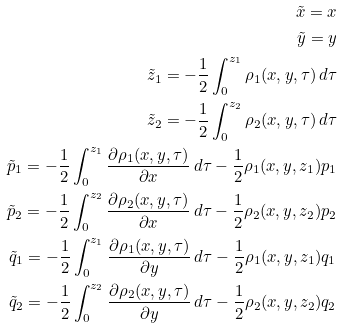<formula> <loc_0><loc_0><loc_500><loc_500>\tilde { x } = x \\ \tilde { y } = y \\ \tilde { z } _ { 1 } = - \frac { 1 } { 2 } \int _ { 0 } ^ { z _ { 1 } } \rho _ { 1 } ( x , y , \tau ) \, d \tau \\ \tilde { z } _ { 2 } = - \frac { 1 } { 2 } \int _ { 0 } ^ { z _ { 2 } } \rho _ { 2 } ( x , y , \tau ) \, d \tau \\ \tilde { p } _ { 1 } = - \frac { 1 } { 2 } \int _ { 0 } ^ { z _ { 1 } } \frac { \partial \rho _ { 1 } ( x , y , \tau ) } { \partial x } \, d \tau - \frac { 1 } { 2 } \rho _ { 1 } ( x , y , z _ { 1 } ) p _ { 1 } \\ \tilde { p } _ { 2 } = - \frac { 1 } { 2 } \int _ { 0 } ^ { z _ { 2 } } \frac { \partial \rho _ { 2 } ( x , y , \tau ) } { \partial x } \, d \tau - \frac { 1 } { 2 } \rho _ { 2 } ( x , y , z _ { 2 } ) p _ { 2 } \\ \tilde { q } _ { 1 } = - \frac { 1 } { 2 } \int _ { 0 } ^ { z _ { 1 } } \frac { \partial \rho _ { 1 } ( x , y , \tau ) } { \partial y } \, d \tau - \frac { 1 } { 2 } \rho _ { 1 } ( x , y , z _ { 1 } ) q _ { 1 } \\ \tilde { q } _ { 2 } = - \frac { 1 } { 2 } \int _ { 0 } ^ { z _ { 2 } } \frac { \partial \rho _ { 2 } ( x , y , \tau ) } { \partial y } \, d \tau - \frac { 1 } { 2 } \rho _ { 2 } ( x , y , z _ { 2 } ) q _ { 2 }</formula> 